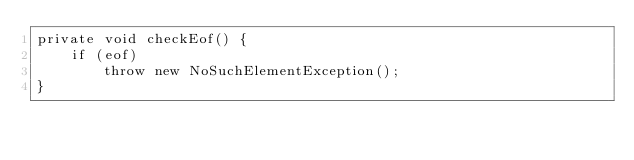<code> <loc_0><loc_0><loc_500><loc_500><_Java_>private void checkEof() {
    if (eof)
        throw new NoSuchElementException();
}</code> 